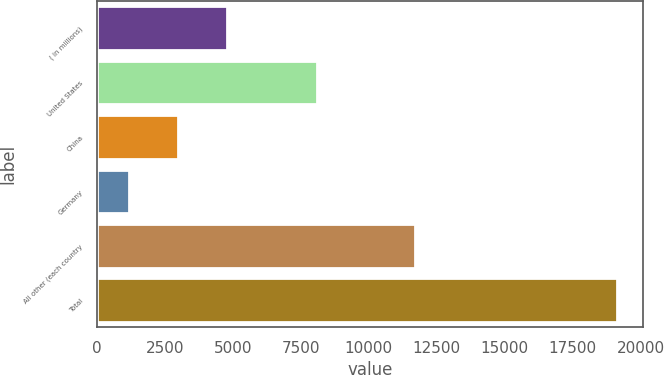<chart> <loc_0><loc_0><loc_500><loc_500><bar_chart><fcel>( in millions)<fcel>United States<fcel>China<fcel>Germany<fcel>All other (each country<fcel>Total<nl><fcel>4777.12<fcel>8091.2<fcel>2980.01<fcel>1182.9<fcel>11685.4<fcel>19154<nl></chart> 